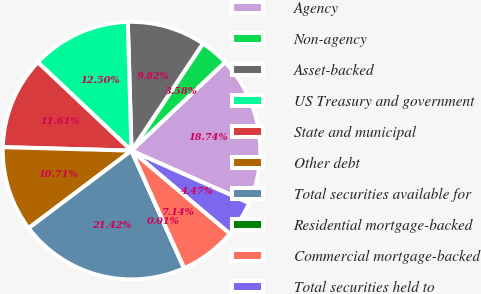Convert chart to OTSL. <chart><loc_0><loc_0><loc_500><loc_500><pie_chart><fcel>Agency<fcel>Non-agency<fcel>Asset-backed<fcel>US Treasury and government<fcel>State and municipal<fcel>Other debt<fcel>Total securities available for<fcel>Residential mortgage-backed<fcel>Commercial mortgage-backed<fcel>Total securities held to<nl><fcel>18.74%<fcel>3.58%<fcel>9.82%<fcel>12.5%<fcel>11.61%<fcel>10.71%<fcel>21.42%<fcel>0.01%<fcel>7.14%<fcel>4.47%<nl></chart> 